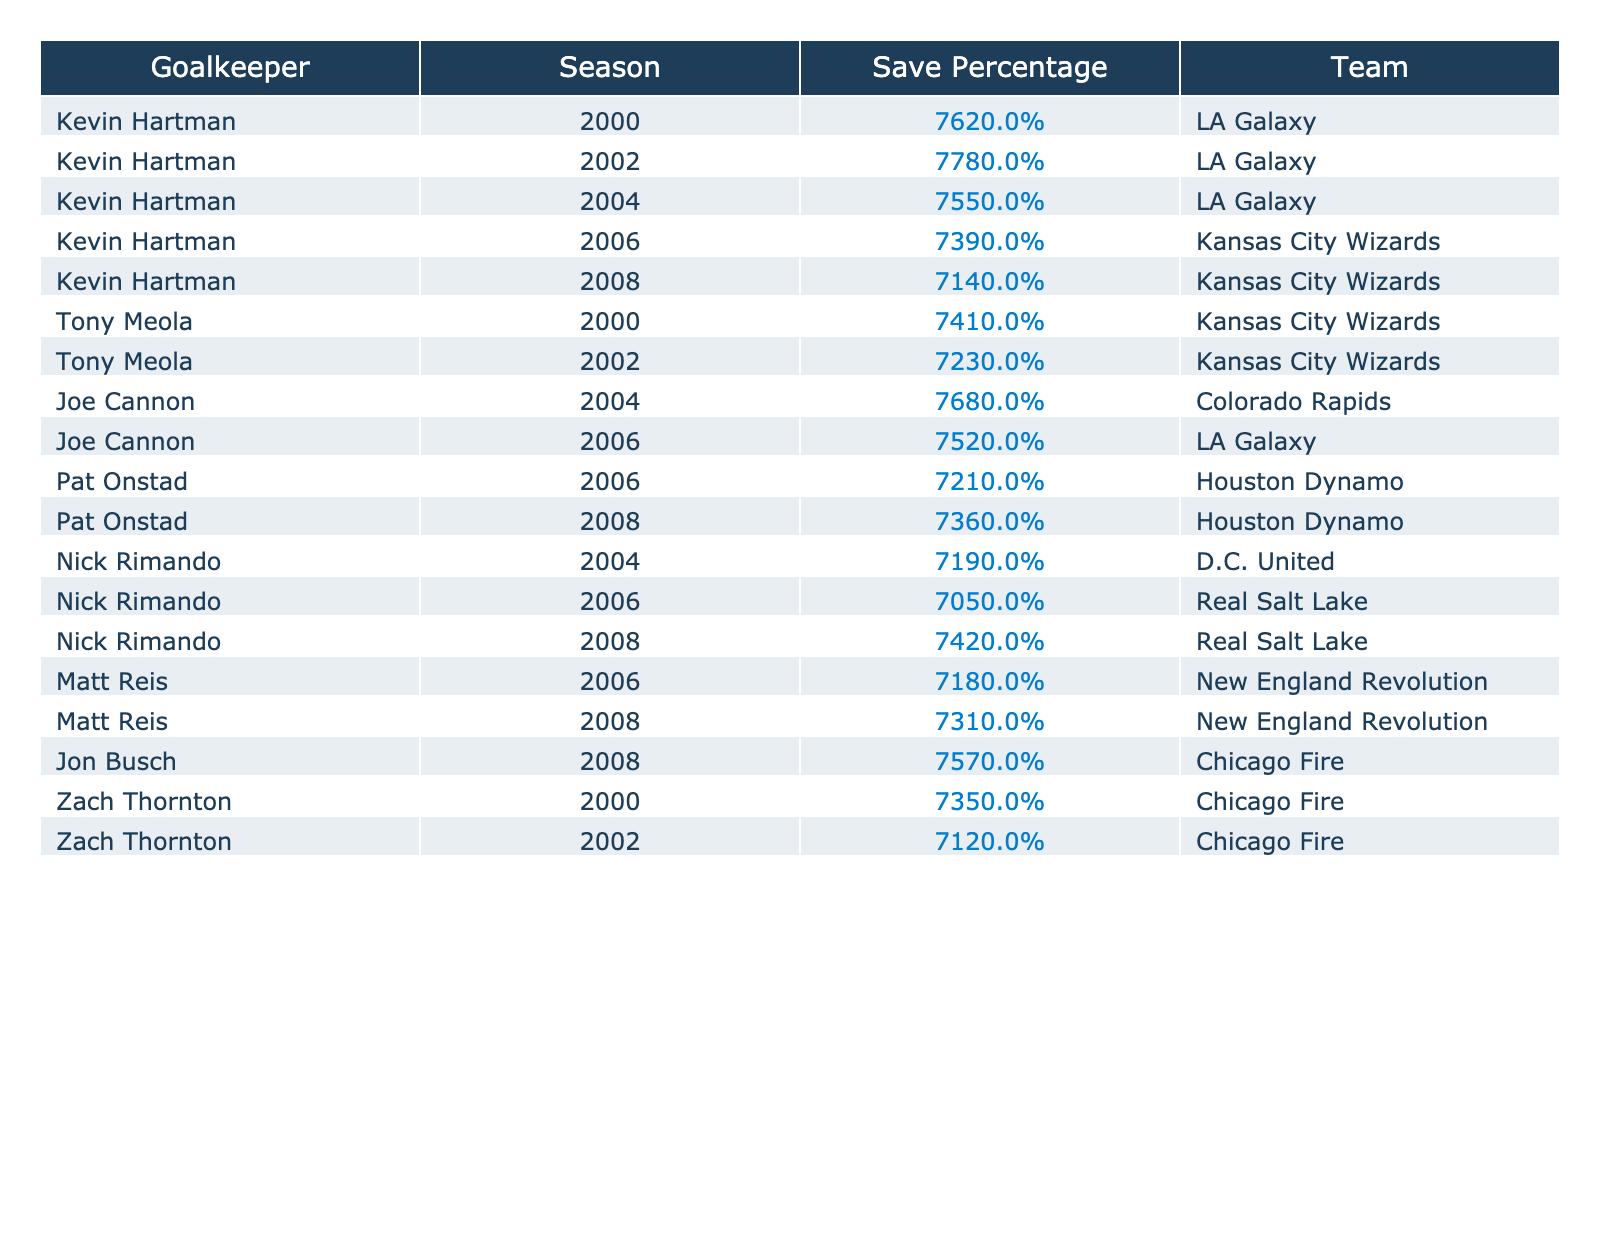What was Kevin Hartman's highest save percentage in a season? The table shows Kevin Hartman's save percentages for various seasons. The highest percentage listed is 77.8%, which is from the year 2002.
Answer: 77.8% Which goalkeeper had the lowest save percentage in 2006? In 2006, Nick Rimando had the lowest save percentage at 70.5%. The data for that season indicates his performance compared to others.
Answer: 70.5% How many seasons did Kevin Hartman have a save percentage above 75%? By checking the seasons listed for Kevin Hartman, there are three instances where his save percentage exceeded 75%: in 2000 (76.2%), 2002 (77.8%), and 2004 (75.5%).
Answer: 3 Was Joe Cannon's save percentage higher than Matt Reis in 2006? In 2006, Joe Cannon had a save percentage of 75.2%, whereas Matt Reis had 71.8%. Therefore, Joe Cannon's percentage was higher than Matt Reis's that season.
Answer: Yes What is the average save percentage for Pat Onstad across the seasons listed? Pat Onstad's save percentages are 72.1% in 2006 and 73.6% in 2008. The average is calculated as (72.1 + 73.6) / 2 = 72.85%.
Answer: 72.85% Did any goalkeeper save over 75% more than once? Kevin Hartman saved over 75% in two seasons (2000 with 76.2% and 2002 with 77.8%). Thus, yes, at least one goalkeeper did achieve this.
Answer: Yes In terms of team performance, which goalkeeper had the highest save percentage for Kansas City Wizards? For Kansas City Wizards, Kevin Hartman had a save percentage of 73.9% in 2006, and that is the highest listed for any goalkeeper on that team.
Answer: 73.9% Taking all seasons into account, which goalkeeper had the highest save percentage across all listed seasons? The highest save percentage in the table is 77.8% held by Kevin Hartman in 2002, making him the top performer in this respect.
Answer: 77.8% What is the difference between Kevin Hartman's save percentage in 2000 and 2008? In 2000, Hartman's save percentage was 76.2%, and in 2008, it was 71.4%. The difference is 76.2% - 71.4% = 4.8%.
Answer: 4.8% How did Nick Rimando's save percentage in 2008 compare to Tony Meola's in 2002? Nick Rimando had a save percentage of 74.2% in 2008, while Tony Meola had 72.3% in 2002. Rimando's percentage was higher by 1.9%.
Answer: Higher by 1.9% 